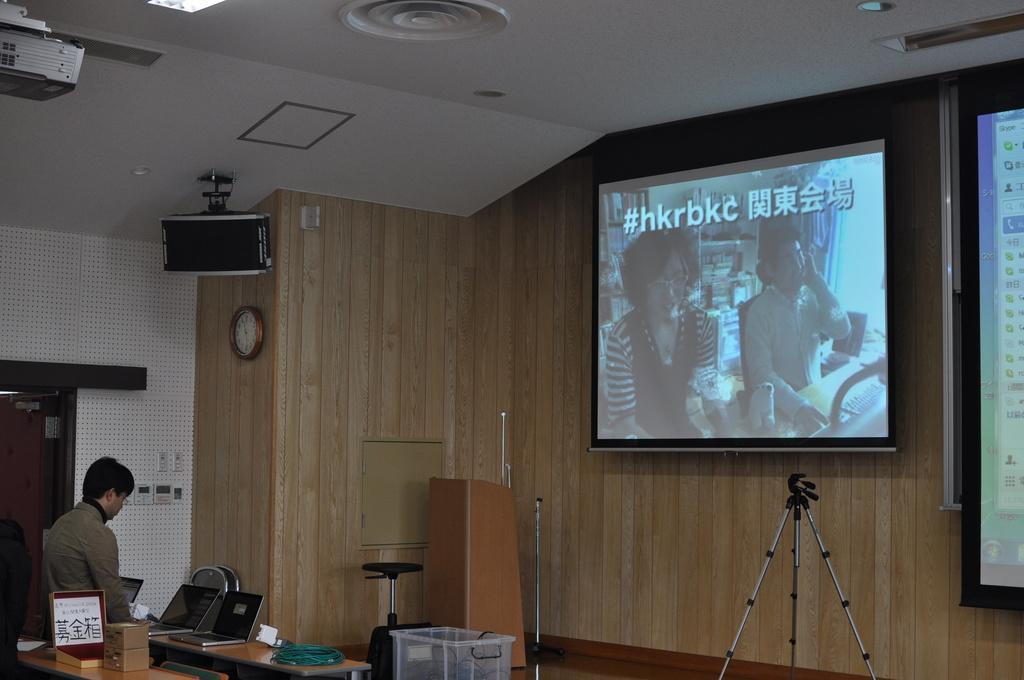How would you summarize this image in a sentence or two? On the left side of the image we can see a person standing behind a table and there are laptops and a few other objects on it, in front of him there is a tripod, a chair, a table, a podium and a screen on which some text and picture are projects, beside it there is another screen, we can see a projector, a clock and a speaker on the wall. 